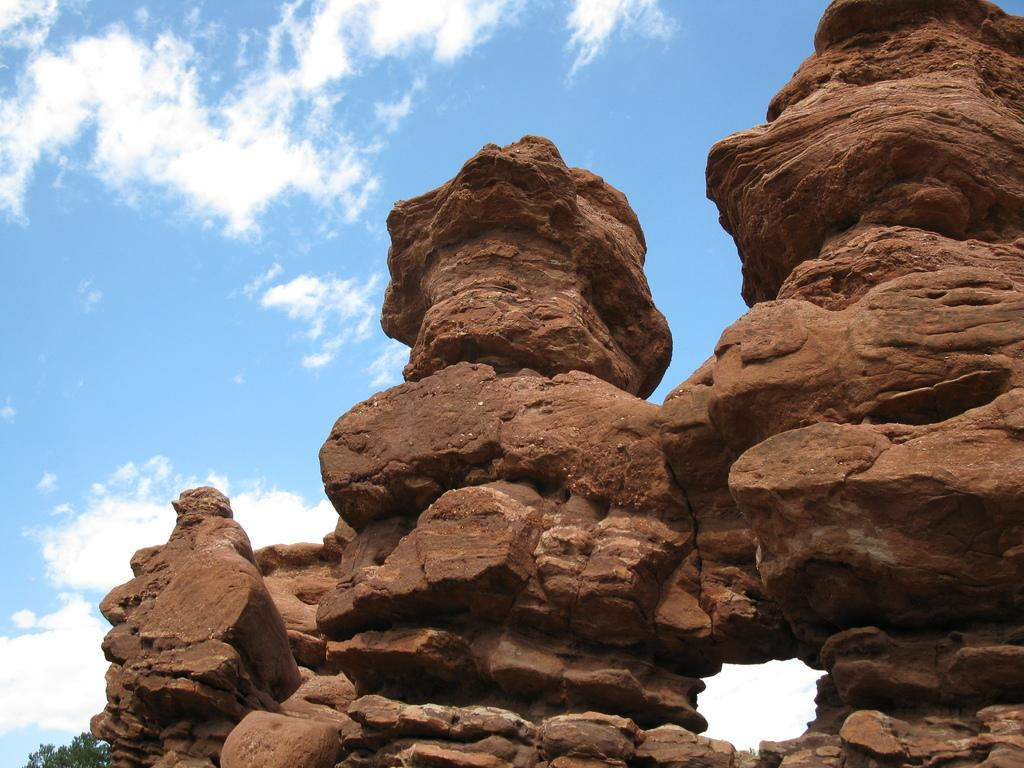What type of natural formations can be seen in the image? There are big rocks in the image. Where are the rocks located in the image? The rocks are at the top of the image. What is visible in the background of the image? The sky is visible in the image. How would you describe the weather based on the sky in the image? The sky is sunny in the image. What type of army activity is taking place in the image? There is no army activity present in the image; it features big rocks at the top of the image with a sunny sky in the background. What trick can be seen being performed with the rocks in the image? There is no trick being performed with the rocks in the image; they are simply large natural formations. 